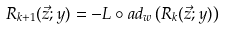Convert formula to latex. <formula><loc_0><loc_0><loc_500><loc_500>R _ { k + 1 } ( \vec { z } ; y ) = - L \circ a d _ { w } \left ( R _ { k } ( \vec { z } ; y ) \right )</formula> 